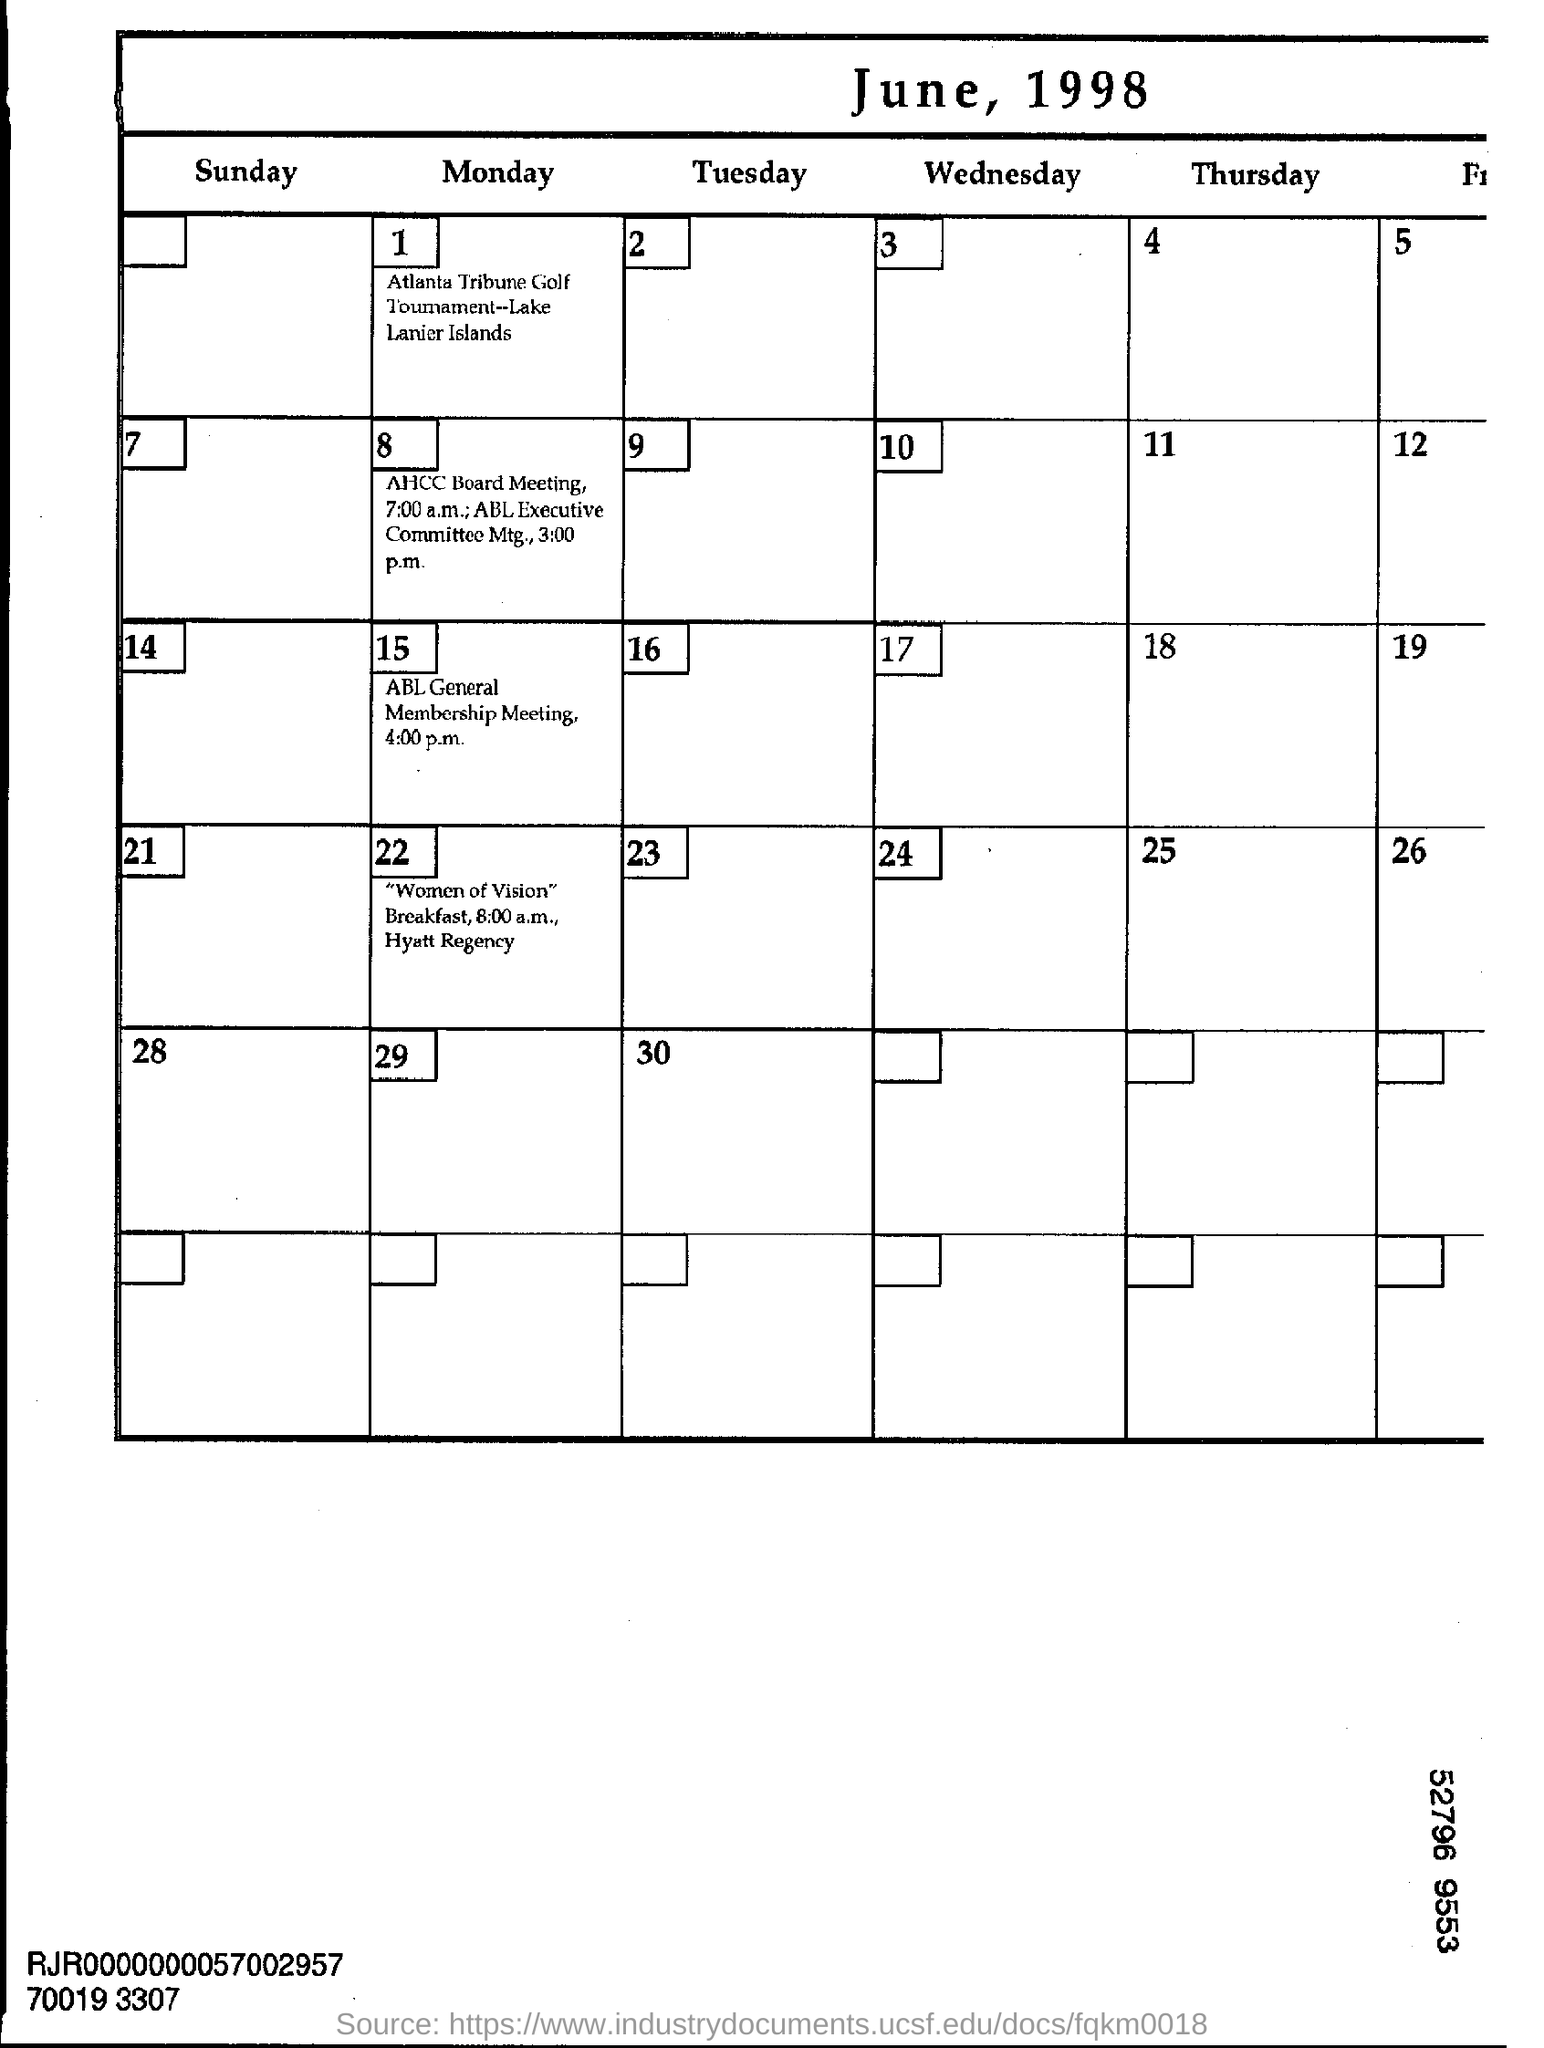List a handful of essential elements in this visual. The Atlanta Tribune Golf Tournament will take place on June 1, 1998. The AHCC Board Meeting will start at 7:00 a.m. The Atlanta Tribune Golf Tournament will be held at Lake Lanier Islands. The ABL Executive Committee meeting will commence at 3:00 p.m. The ABL General Membership Meeting is scheduled to begin at 4:00 p.m. 